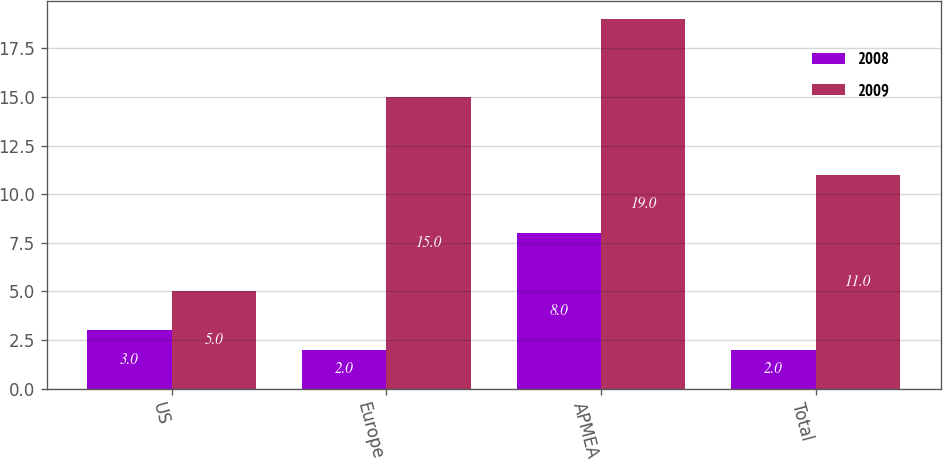<chart> <loc_0><loc_0><loc_500><loc_500><stacked_bar_chart><ecel><fcel>US<fcel>Europe<fcel>APMEA<fcel>Total<nl><fcel>2008<fcel>3<fcel>2<fcel>8<fcel>2<nl><fcel>2009<fcel>5<fcel>15<fcel>19<fcel>11<nl></chart> 